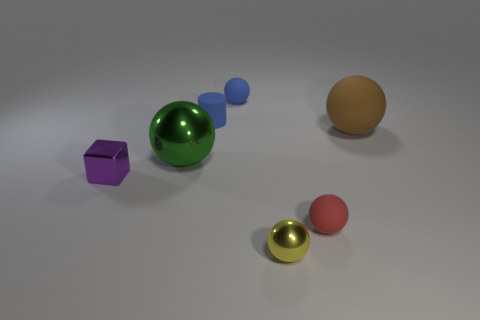How many other objects are the same material as the big green ball?
Keep it short and to the point. 2. Are there any green shiny things to the right of the red rubber thing?
Offer a very short reply. No. Do the block and the shiny ball to the left of the small yellow ball have the same size?
Your answer should be very brief. No. The tiny ball on the left side of the shiny ball in front of the tiny purple metal thing is what color?
Make the answer very short. Blue. Do the purple shiny cube and the green thing have the same size?
Give a very brief answer. No. There is a rubber ball that is left of the brown rubber thing and on the right side of the small yellow sphere; what color is it?
Your response must be concise. Red. The green thing has what size?
Provide a short and direct response. Large. Do the metal sphere in front of the green ball and the big shiny ball have the same color?
Offer a terse response. No. Is the number of purple objects that are to the right of the small purple thing greater than the number of tiny matte objects that are to the right of the yellow sphere?
Give a very brief answer. No. Is the number of purple things greater than the number of big gray things?
Make the answer very short. Yes. 